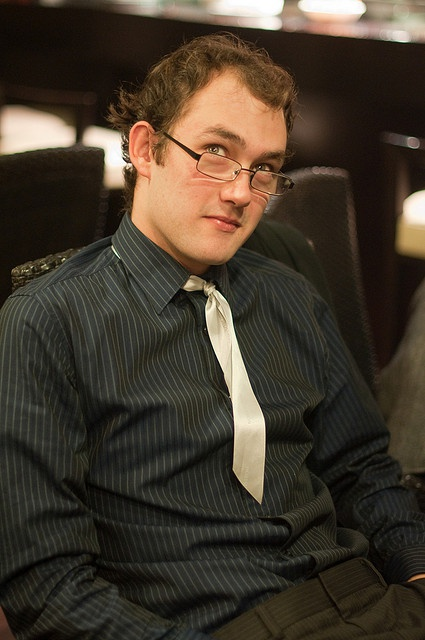Describe the objects in this image and their specific colors. I can see people in black, tan, and gray tones, chair in black and gray tones, chair in black, gray, and maroon tones, tie in black, tan, and beige tones, and chair in black, darkgreen, and gray tones in this image. 